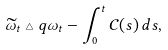Convert formula to latex. <formula><loc_0><loc_0><loc_500><loc_500>\widetilde { \omega } _ { t } \triangle q \omega _ { t } - \int _ { 0 } ^ { t } \mathcal { C } ( s ) \, d s ,</formula> 